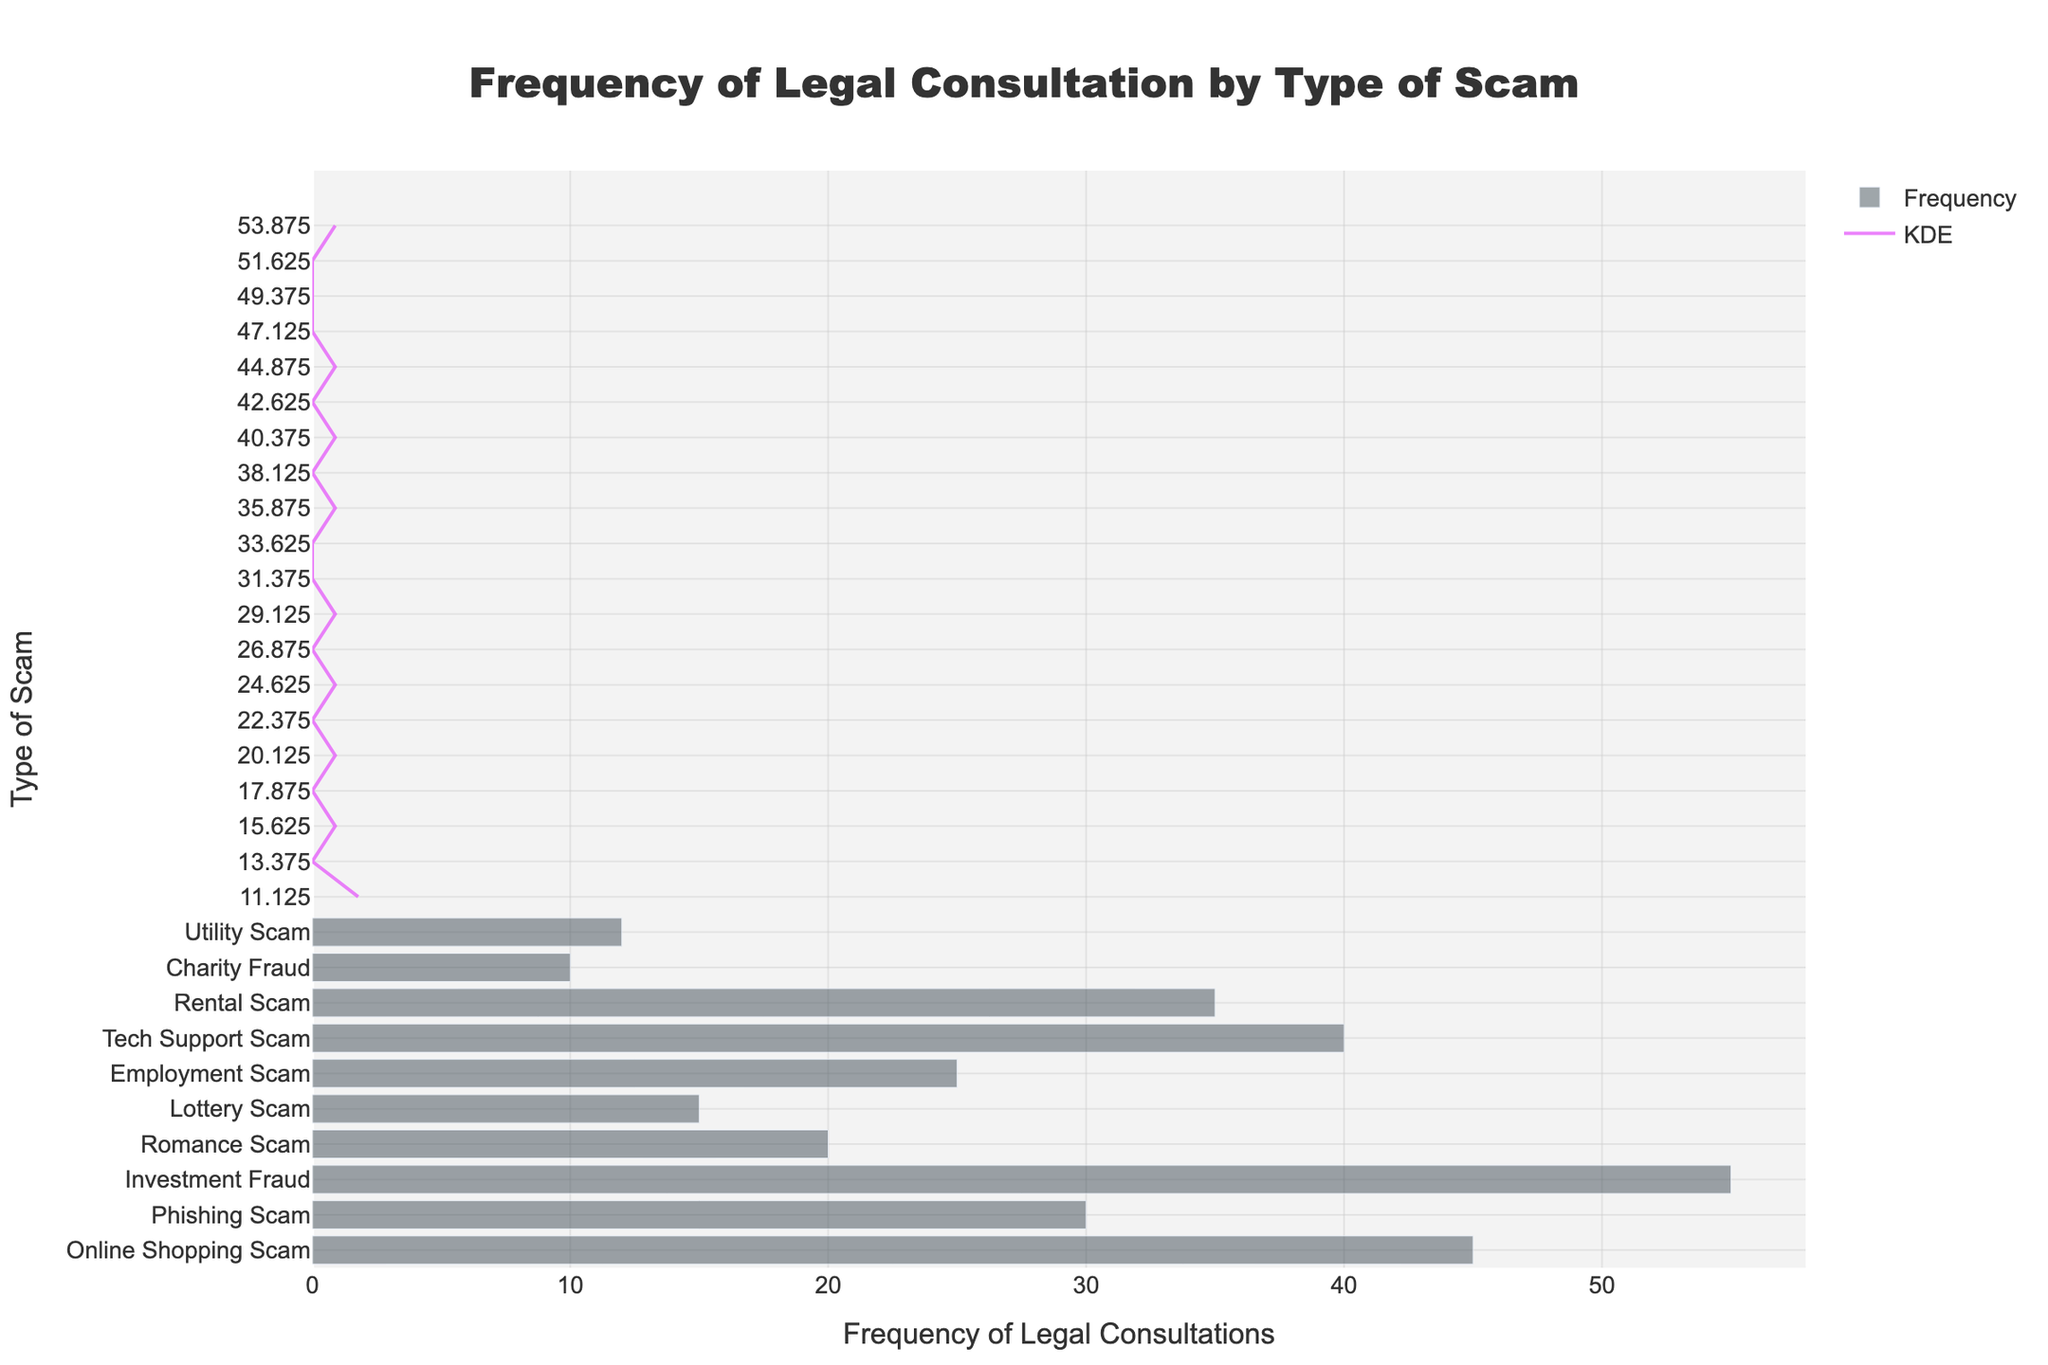What's the title of the plot? The title of the plot is usually displayed at the top of the figure in a larger and bold font. In this case, it reads "Frequency of Legal Consultation by Type of Scam."
Answer: Frequency of Legal Consultation by Type of Scam Which type of scam has the highest frequency of legal consultations? By looking at the horizontal bar that extends the farthest to the right, we can see "Investment Fraud" is the type of scam with the highest frequency of legal consultations.
Answer: Investment Fraud How many legal consultations are associated with the "Tech Support Scam"? Locate the bar labeled "Tech Support Scam" on the y-axis and follow it to where it intersects with the x-axis, showing the frequency is 40 legal consultations.
Answer: 40 What's the median frequency of legal consultations across all scam types? To find the median, list all the reported frequencies in order. The median is the middle value. The ordered list is: 10, 12, 15, 20, 25, 30, 35, 40, 45, 55. Therefore, the median is the average of the 5th and 6th values: (25 + 30)/2 = 27.5.
Answer: 27.5 Which scam type has fewer legal consultations than "Tech Support Scam" but more than "Online Shopping Scam"? "Tech Support Scam" has 40 legal consultations and "Online Shopping Scam" has 45. The only type with fewer than 40 but more than 45 is "Rental Scam" with 35 legal consultations.
Answer: Rental Scam What is the difference in legal consultations between "Phishing Scam" and "Lottery Scam"? "Phishing Scam" has 30 legal consultations and "Lottery Scam" has 15. The difference is found by subtracting 15 from 30, which equals 15.
Answer: 15 Which scam types have fewer than 20 legal consultations? By examining the bars, we identify "Charity Fraud," "Utility Scam," "Lottery Scam," and "Romance Scam" all have fewer than 20 legal consultations.
Answer: Charity Fraud, Utility Scam, Lottery Scam, Romance Scam What does the KDE line represent in this plot? In the context of this figure, the KDE (Kernel Density Estimation) line provides a smoothed visualization of the distribution of the frequency of legal consultations across different scam types. It helps to highlight the density of occurrences at various frequency levels.
Answer: Smoothed distribution of frequencies How many scam types have more than 30 legal consultations? Count the bars that extend beyond 30 on the x-axis. The types are "Online Shopping Scam," "Phishing Scam," "Investment Fraud," "Tech Support Scam," and "Rental Scam," making it five in total.
Answer: 5 